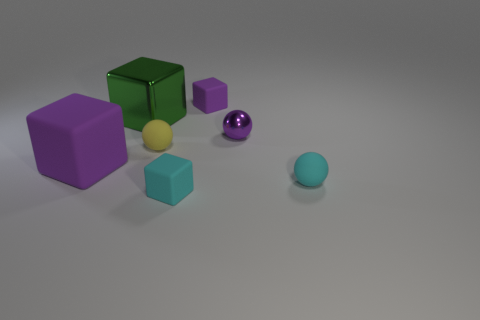Is the material of the tiny purple ball the same as the large purple thing?
Keep it short and to the point. No. There is a shiny object in front of the large cube that is right of the matte thing that is to the left of the big metal object; what size is it?
Your answer should be very brief. Small. What number of other things are the same color as the big matte thing?
Provide a succinct answer. 2. What is the shape of the metallic thing that is the same size as the yellow ball?
Your answer should be very brief. Sphere. How many big things are either green cylinders or yellow rubber things?
Your answer should be compact. 0. Are there any small shiny spheres left of the small cyan matte thing on the left side of the small ball in front of the big rubber cube?
Your answer should be very brief. No. Are there any cyan rubber blocks that have the same size as the metallic cube?
Your response must be concise. No. What material is the cube that is the same size as the green object?
Provide a short and direct response. Rubber. There is a metal sphere; is its size the same as the purple matte thing that is on the right side of the cyan cube?
Make the answer very short. Yes. What number of metal things are tiny purple cubes or small red things?
Your answer should be very brief. 0. 